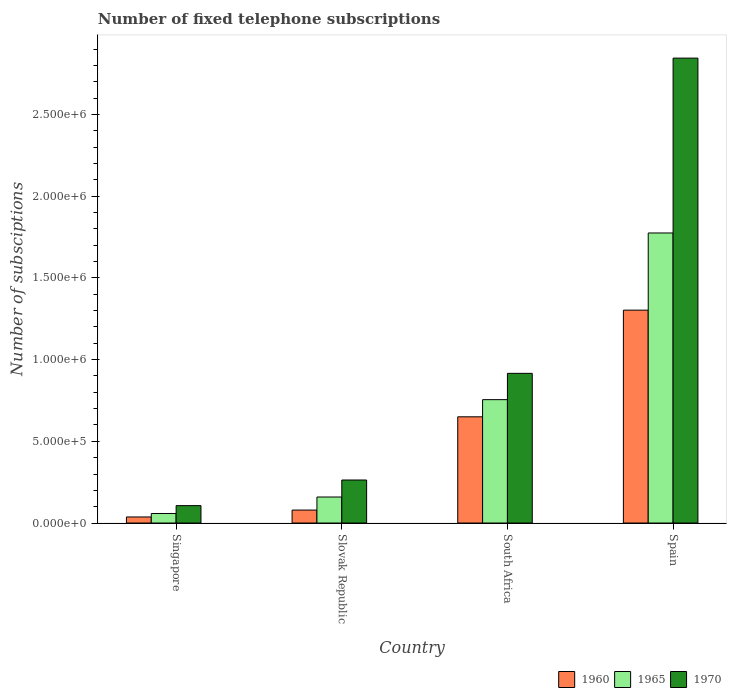How many different coloured bars are there?
Ensure brevity in your answer.  3. How many groups of bars are there?
Your answer should be very brief. 4. Are the number of bars per tick equal to the number of legend labels?
Offer a terse response. Yes. How many bars are there on the 4th tick from the left?
Offer a terse response. 3. What is the label of the 1st group of bars from the left?
Ensure brevity in your answer.  Singapore. What is the number of fixed telephone subscriptions in 1965 in Singapore?
Offer a terse response. 5.84e+04. Across all countries, what is the maximum number of fixed telephone subscriptions in 1960?
Give a very brief answer. 1.30e+06. Across all countries, what is the minimum number of fixed telephone subscriptions in 1965?
Ensure brevity in your answer.  5.84e+04. In which country was the number of fixed telephone subscriptions in 1970 maximum?
Your answer should be very brief. Spain. In which country was the number of fixed telephone subscriptions in 1970 minimum?
Give a very brief answer. Singapore. What is the total number of fixed telephone subscriptions in 1960 in the graph?
Your answer should be very brief. 2.07e+06. What is the difference between the number of fixed telephone subscriptions in 1960 in Slovak Republic and that in Spain?
Give a very brief answer. -1.22e+06. What is the difference between the number of fixed telephone subscriptions in 1965 in Spain and the number of fixed telephone subscriptions in 1970 in South Africa?
Ensure brevity in your answer.  8.59e+05. What is the average number of fixed telephone subscriptions in 1960 per country?
Keep it short and to the point. 5.17e+05. What is the difference between the number of fixed telephone subscriptions of/in 1960 and number of fixed telephone subscriptions of/in 1965 in Slovak Republic?
Give a very brief answer. -7.99e+04. What is the ratio of the number of fixed telephone subscriptions in 1965 in Slovak Republic to that in Spain?
Your answer should be very brief. 0.09. Is the number of fixed telephone subscriptions in 1965 in Slovak Republic less than that in Spain?
Ensure brevity in your answer.  Yes. Is the difference between the number of fixed telephone subscriptions in 1960 in Singapore and Spain greater than the difference between the number of fixed telephone subscriptions in 1965 in Singapore and Spain?
Offer a very short reply. Yes. What is the difference between the highest and the second highest number of fixed telephone subscriptions in 1970?
Provide a succinct answer. 2.58e+06. What is the difference between the highest and the lowest number of fixed telephone subscriptions in 1960?
Give a very brief answer. 1.27e+06. What does the 2nd bar from the left in South Africa represents?
Make the answer very short. 1965. What does the 1st bar from the right in Slovak Republic represents?
Ensure brevity in your answer.  1970. Are the values on the major ticks of Y-axis written in scientific E-notation?
Your answer should be very brief. Yes. Does the graph contain grids?
Give a very brief answer. No. Where does the legend appear in the graph?
Ensure brevity in your answer.  Bottom right. What is the title of the graph?
Keep it short and to the point. Number of fixed telephone subscriptions. What is the label or title of the X-axis?
Your response must be concise. Country. What is the label or title of the Y-axis?
Provide a short and direct response. Number of subsciptions. What is the Number of subsciptions of 1960 in Singapore?
Ensure brevity in your answer.  3.71e+04. What is the Number of subsciptions of 1965 in Singapore?
Offer a very short reply. 5.84e+04. What is the Number of subsciptions in 1970 in Singapore?
Your response must be concise. 1.06e+05. What is the Number of subsciptions of 1960 in Slovak Republic?
Your answer should be compact. 7.93e+04. What is the Number of subsciptions of 1965 in Slovak Republic?
Your response must be concise. 1.59e+05. What is the Number of subsciptions in 1970 in Slovak Republic?
Your answer should be very brief. 2.63e+05. What is the Number of subsciptions of 1960 in South Africa?
Provide a short and direct response. 6.50e+05. What is the Number of subsciptions in 1965 in South Africa?
Your answer should be very brief. 7.55e+05. What is the Number of subsciptions of 1970 in South Africa?
Provide a succinct answer. 9.16e+05. What is the Number of subsciptions of 1960 in Spain?
Make the answer very short. 1.30e+06. What is the Number of subsciptions in 1965 in Spain?
Your response must be concise. 1.78e+06. What is the Number of subsciptions in 1970 in Spain?
Offer a very short reply. 2.84e+06. Across all countries, what is the maximum Number of subsciptions of 1960?
Your response must be concise. 1.30e+06. Across all countries, what is the maximum Number of subsciptions of 1965?
Your answer should be compact. 1.78e+06. Across all countries, what is the maximum Number of subsciptions of 1970?
Provide a succinct answer. 2.84e+06. Across all countries, what is the minimum Number of subsciptions of 1960?
Your answer should be compact. 3.71e+04. Across all countries, what is the minimum Number of subsciptions of 1965?
Offer a terse response. 5.84e+04. Across all countries, what is the minimum Number of subsciptions in 1970?
Offer a terse response. 1.06e+05. What is the total Number of subsciptions of 1960 in the graph?
Your response must be concise. 2.07e+06. What is the total Number of subsciptions of 1965 in the graph?
Ensure brevity in your answer.  2.75e+06. What is the total Number of subsciptions of 1970 in the graph?
Keep it short and to the point. 4.13e+06. What is the difference between the Number of subsciptions in 1960 in Singapore and that in Slovak Republic?
Your answer should be compact. -4.22e+04. What is the difference between the Number of subsciptions in 1965 in Singapore and that in Slovak Republic?
Give a very brief answer. -1.01e+05. What is the difference between the Number of subsciptions of 1970 in Singapore and that in Slovak Republic?
Your response must be concise. -1.57e+05. What is the difference between the Number of subsciptions in 1960 in Singapore and that in South Africa?
Your response must be concise. -6.13e+05. What is the difference between the Number of subsciptions in 1965 in Singapore and that in South Africa?
Give a very brief answer. -6.97e+05. What is the difference between the Number of subsciptions in 1970 in Singapore and that in South Africa?
Offer a terse response. -8.10e+05. What is the difference between the Number of subsciptions of 1960 in Singapore and that in Spain?
Provide a succinct answer. -1.27e+06. What is the difference between the Number of subsciptions in 1965 in Singapore and that in Spain?
Ensure brevity in your answer.  -1.72e+06. What is the difference between the Number of subsciptions in 1970 in Singapore and that in Spain?
Your response must be concise. -2.74e+06. What is the difference between the Number of subsciptions of 1960 in Slovak Republic and that in South Africa?
Your answer should be compact. -5.71e+05. What is the difference between the Number of subsciptions of 1965 in Slovak Republic and that in South Africa?
Provide a short and direct response. -5.96e+05. What is the difference between the Number of subsciptions of 1970 in Slovak Republic and that in South Africa?
Ensure brevity in your answer.  -6.53e+05. What is the difference between the Number of subsciptions in 1960 in Slovak Republic and that in Spain?
Provide a short and direct response. -1.22e+06. What is the difference between the Number of subsciptions of 1965 in Slovak Republic and that in Spain?
Offer a terse response. -1.62e+06. What is the difference between the Number of subsciptions of 1970 in Slovak Republic and that in Spain?
Keep it short and to the point. -2.58e+06. What is the difference between the Number of subsciptions of 1960 in South Africa and that in Spain?
Ensure brevity in your answer.  -6.53e+05. What is the difference between the Number of subsciptions of 1965 in South Africa and that in Spain?
Provide a succinct answer. -1.02e+06. What is the difference between the Number of subsciptions in 1970 in South Africa and that in Spain?
Give a very brief answer. -1.93e+06. What is the difference between the Number of subsciptions in 1960 in Singapore and the Number of subsciptions in 1965 in Slovak Republic?
Offer a terse response. -1.22e+05. What is the difference between the Number of subsciptions of 1960 in Singapore and the Number of subsciptions of 1970 in Slovak Republic?
Your answer should be compact. -2.26e+05. What is the difference between the Number of subsciptions in 1965 in Singapore and the Number of subsciptions in 1970 in Slovak Republic?
Provide a succinct answer. -2.05e+05. What is the difference between the Number of subsciptions of 1960 in Singapore and the Number of subsciptions of 1965 in South Africa?
Offer a very short reply. -7.18e+05. What is the difference between the Number of subsciptions in 1960 in Singapore and the Number of subsciptions in 1970 in South Africa?
Offer a very short reply. -8.79e+05. What is the difference between the Number of subsciptions of 1965 in Singapore and the Number of subsciptions of 1970 in South Africa?
Your answer should be very brief. -8.58e+05. What is the difference between the Number of subsciptions of 1960 in Singapore and the Number of subsciptions of 1965 in Spain?
Keep it short and to the point. -1.74e+06. What is the difference between the Number of subsciptions in 1960 in Singapore and the Number of subsciptions in 1970 in Spain?
Provide a short and direct response. -2.81e+06. What is the difference between the Number of subsciptions in 1965 in Singapore and the Number of subsciptions in 1970 in Spain?
Give a very brief answer. -2.79e+06. What is the difference between the Number of subsciptions of 1960 in Slovak Republic and the Number of subsciptions of 1965 in South Africa?
Give a very brief answer. -6.76e+05. What is the difference between the Number of subsciptions in 1960 in Slovak Republic and the Number of subsciptions in 1970 in South Africa?
Ensure brevity in your answer.  -8.37e+05. What is the difference between the Number of subsciptions of 1965 in Slovak Republic and the Number of subsciptions of 1970 in South Africa?
Make the answer very short. -7.57e+05. What is the difference between the Number of subsciptions in 1960 in Slovak Republic and the Number of subsciptions in 1965 in Spain?
Keep it short and to the point. -1.70e+06. What is the difference between the Number of subsciptions of 1960 in Slovak Republic and the Number of subsciptions of 1970 in Spain?
Keep it short and to the point. -2.77e+06. What is the difference between the Number of subsciptions of 1965 in Slovak Republic and the Number of subsciptions of 1970 in Spain?
Ensure brevity in your answer.  -2.69e+06. What is the difference between the Number of subsciptions of 1960 in South Africa and the Number of subsciptions of 1965 in Spain?
Your answer should be compact. -1.12e+06. What is the difference between the Number of subsciptions in 1960 in South Africa and the Number of subsciptions in 1970 in Spain?
Offer a terse response. -2.19e+06. What is the difference between the Number of subsciptions of 1965 in South Africa and the Number of subsciptions of 1970 in Spain?
Provide a succinct answer. -2.09e+06. What is the average Number of subsciptions of 1960 per country?
Ensure brevity in your answer.  5.17e+05. What is the average Number of subsciptions of 1965 per country?
Ensure brevity in your answer.  6.87e+05. What is the average Number of subsciptions in 1970 per country?
Make the answer very short. 1.03e+06. What is the difference between the Number of subsciptions of 1960 and Number of subsciptions of 1965 in Singapore?
Keep it short and to the point. -2.13e+04. What is the difference between the Number of subsciptions in 1960 and Number of subsciptions in 1970 in Singapore?
Offer a very short reply. -6.93e+04. What is the difference between the Number of subsciptions in 1965 and Number of subsciptions in 1970 in Singapore?
Offer a very short reply. -4.81e+04. What is the difference between the Number of subsciptions of 1960 and Number of subsciptions of 1965 in Slovak Republic?
Your answer should be very brief. -7.99e+04. What is the difference between the Number of subsciptions of 1960 and Number of subsciptions of 1970 in Slovak Republic?
Your response must be concise. -1.84e+05. What is the difference between the Number of subsciptions in 1965 and Number of subsciptions in 1970 in Slovak Republic?
Make the answer very short. -1.04e+05. What is the difference between the Number of subsciptions of 1960 and Number of subsciptions of 1965 in South Africa?
Provide a short and direct response. -1.05e+05. What is the difference between the Number of subsciptions in 1960 and Number of subsciptions in 1970 in South Africa?
Give a very brief answer. -2.66e+05. What is the difference between the Number of subsciptions in 1965 and Number of subsciptions in 1970 in South Africa?
Provide a short and direct response. -1.61e+05. What is the difference between the Number of subsciptions in 1960 and Number of subsciptions in 1965 in Spain?
Provide a succinct answer. -4.72e+05. What is the difference between the Number of subsciptions of 1960 and Number of subsciptions of 1970 in Spain?
Provide a succinct answer. -1.54e+06. What is the difference between the Number of subsciptions in 1965 and Number of subsciptions in 1970 in Spain?
Make the answer very short. -1.07e+06. What is the ratio of the Number of subsciptions in 1960 in Singapore to that in Slovak Republic?
Provide a succinct answer. 0.47. What is the ratio of the Number of subsciptions of 1965 in Singapore to that in Slovak Republic?
Offer a terse response. 0.37. What is the ratio of the Number of subsciptions of 1970 in Singapore to that in Slovak Republic?
Keep it short and to the point. 0.4. What is the ratio of the Number of subsciptions in 1960 in Singapore to that in South Africa?
Provide a short and direct response. 0.06. What is the ratio of the Number of subsciptions of 1965 in Singapore to that in South Africa?
Offer a very short reply. 0.08. What is the ratio of the Number of subsciptions in 1970 in Singapore to that in South Africa?
Your answer should be very brief. 0.12. What is the ratio of the Number of subsciptions of 1960 in Singapore to that in Spain?
Provide a short and direct response. 0.03. What is the ratio of the Number of subsciptions of 1965 in Singapore to that in Spain?
Provide a succinct answer. 0.03. What is the ratio of the Number of subsciptions of 1970 in Singapore to that in Spain?
Provide a short and direct response. 0.04. What is the ratio of the Number of subsciptions in 1960 in Slovak Republic to that in South Africa?
Offer a very short reply. 0.12. What is the ratio of the Number of subsciptions in 1965 in Slovak Republic to that in South Africa?
Provide a short and direct response. 0.21. What is the ratio of the Number of subsciptions of 1970 in Slovak Republic to that in South Africa?
Give a very brief answer. 0.29. What is the ratio of the Number of subsciptions of 1960 in Slovak Republic to that in Spain?
Provide a succinct answer. 0.06. What is the ratio of the Number of subsciptions in 1965 in Slovak Republic to that in Spain?
Your response must be concise. 0.09. What is the ratio of the Number of subsciptions in 1970 in Slovak Republic to that in Spain?
Your answer should be compact. 0.09. What is the ratio of the Number of subsciptions in 1960 in South Africa to that in Spain?
Your answer should be very brief. 0.5. What is the ratio of the Number of subsciptions in 1965 in South Africa to that in Spain?
Offer a terse response. 0.43. What is the ratio of the Number of subsciptions in 1970 in South Africa to that in Spain?
Make the answer very short. 0.32. What is the difference between the highest and the second highest Number of subsciptions in 1960?
Your answer should be very brief. 6.53e+05. What is the difference between the highest and the second highest Number of subsciptions of 1965?
Provide a succinct answer. 1.02e+06. What is the difference between the highest and the second highest Number of subsciptions of 1970?
Provide a short and direct response. 1.93e+06. What is the difference between the highest and the lowest Number of subsciptions in 1960?
Provide a succinct answer. 1.27e+06. What is the difference between the highest and the lowest Number of subsciptions in 1965?
Give a very brief answer. 1.72e+06. What is the difference between the highest and the lowest Number of subsciptions in 1970?
Offer a very short reply. 2.74e+06. 